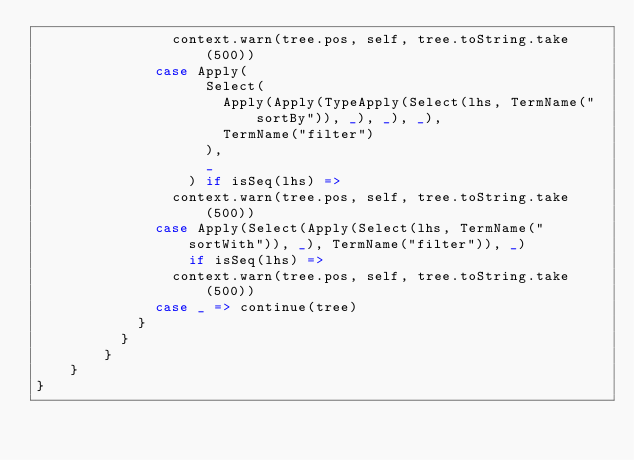Convert code to text. <code><loc_0><loc_0><loc_500><loc_500><_Scala_>                context.warn(tree.pos, self, tree.toString.take(500))
              case Apply(
                    Select(
                      Apply(Apply(TypeApply(Select(lhs, TermName("sortBy")), _), _), _),
                      TermName("filter")
                    ),
                    _
                  ) if isSeq(lhs) =>
                context.warn(tree.pos, self, tree.toString.take(500))
              case Apply(Select(Apply(Select(lhs, TermName("sortWith")), _), TermName("filter")), _)
                  if isSeq(lhs) =>
                context.warn(tree.pos, self, tree.toString.take(500))
              case _ => continue(tree)
            }
          }
        }
    }
}
</code> 